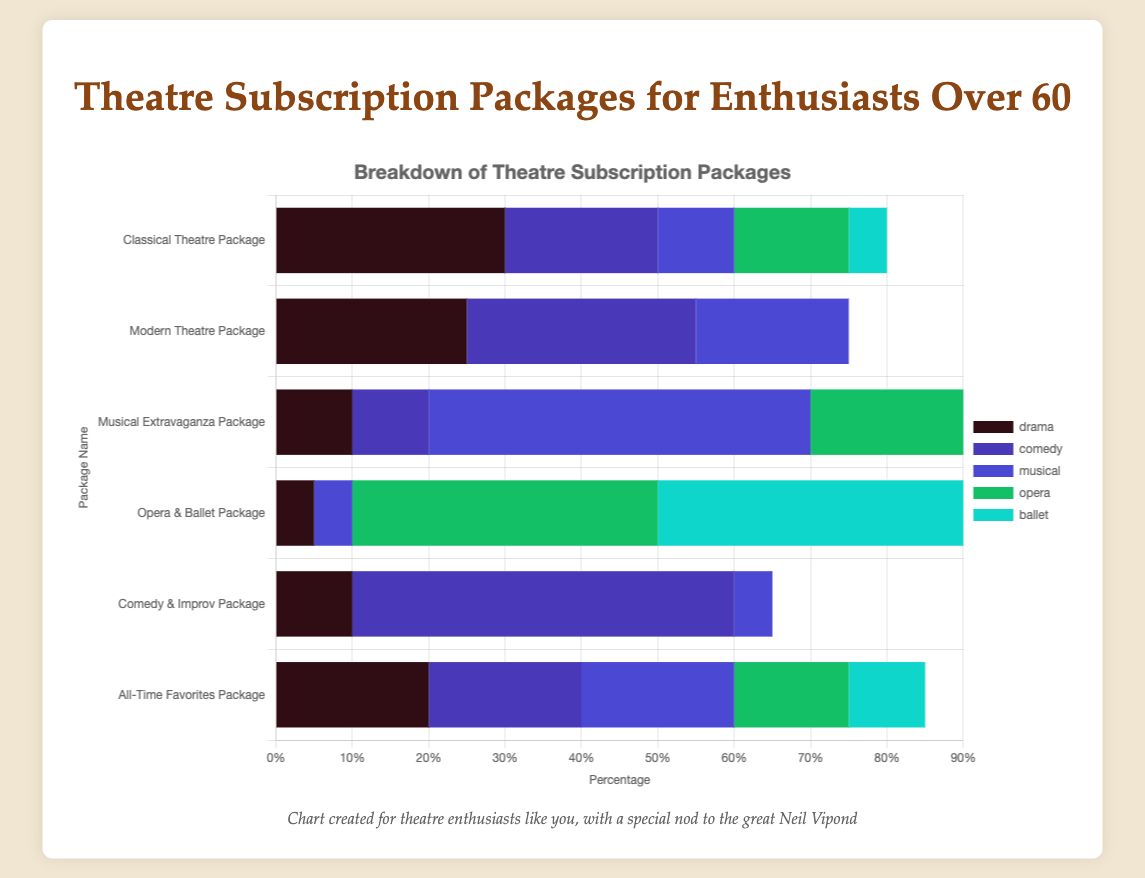What is the percentage of drama in the Classical Theatre Package? To find this, locate the Classical Theatre Package bar and look for the section labeled "drama." The percentage value is indicated within or next to that section. It is 30%.
Answer: 30% Which package has the highest percentage of comedy? Look at each bar in the chart to find the sections labeled "comedy." The tallest/completely filled comedy section will indicate the highest percentage. The Comedy & Improv Package has the highest value with 50%.
Answer: Comedy & Improv Package How does the distribution of opera in the Musical Extravaganza Package compare to the Opera & Ballet Package? Identify the "opera" sections in both the Musical Extravaganza and Opera & Ballet Packages. In the Musical Extravaganza Package, the opera section is smaller (20%) compared to the Opera & Ballet Package (40%).
Answer: Opera & Ballet Package has more What is the total percentage of non-drama categories in the Classical Theatre Package? For the Classical Theatre Package, the non-drama categories are comedy, musical, opera, and ballet. Add the percentages: 20 (comedy) + 10 (musical) + 15 (opera) + 5 (ballet) = 50%.
Answer: 50% Which package has the most balanced distribution across categories? Observe all packages and see which one has the most evenly sized sections across various categories. The All-Time Favorites Package seems the most balanced with drama, comedy, musical all at 20%, and others relatively evenly distributed.
Answer: All-Time Favorites Package What is the difference in the percentage of musical in the Classical Theatre Package and the Musical Extravaganza Package? Identify the musical percentage for both packages: Classical Theatre Package has 10%, and Musical Extravaganza Package has 50%. The difference is 50 - 10, which equals 40%.
Answer: 40% Which category appears most frequently as the largest section across all packages? Examine the largest sections for each package bar. Comedy appears most frequently as the largest section in packages like the Modern Theatre and Comedy & Improv Packages.
Answer: Comedy What percentage does the experimental category contribute to the Modern Theatre Package? Locate the experimental section within the Modern Theatre Package bar. It shows 15%.
Answer: 15% How does the drama percentage in the Comedy & Improv Package compare to the All-Time Favorites Package? Find the drama sections in both packages. Comedy & Improv Package has 10% for drama, while All-Time Favorites Package has 20%. The All-Time Favorites has a higher drama percentage.
Answer: All-Time Favorites Package has more Which package has the smallest percentage of opera? Observe all sections labeled "opera" across different packages. The smallest appears in the Comedy & Improv Package and All-Time Favorites Package, both showing only 5%.
Answer: Comedy & Improv Package and All-Time Favorites Package 